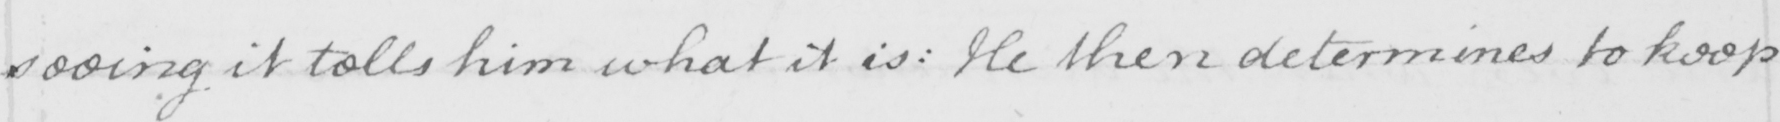Transcribe the text shown in this historical manuscript line. seeing it tells him what it is :  He then determines to keep 